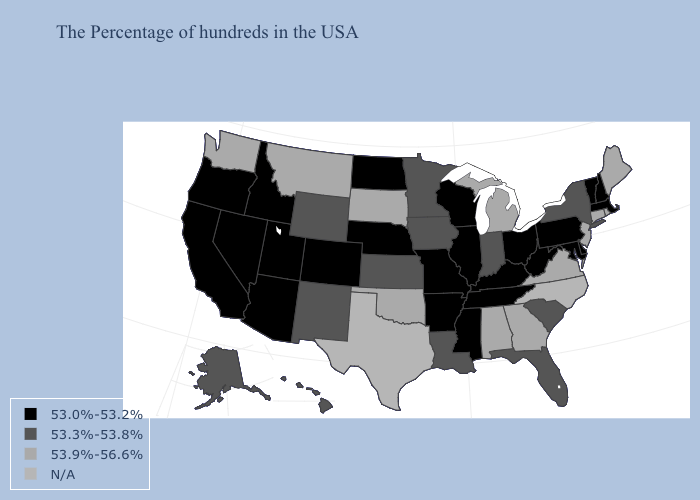Which states hav the highest value in the West?
Quick response, please. Montana, Washington. What is the value of Missouri?
Write a very short answer. 53.0%-53.2%. Name the states that have a value in the range 53.0%-53.2%?
Answer briefly. Massachusetts, New Hampshire, Vermont, Delaware, Maryland, Pennsylvania, West Virginia, Ohio, Kentucky, Tennessee, Wisconsin, Illinois, Mississippi, Missouri, Arkansas, Nebraska, North Dakota, Colorado, Utah, Arizona, Idaho, Nevada, California, Oregon. What is the lowest value in the USA?
Give a very brief answer. 53.0%-53.2%. What is the value of Louisiana?
Quick response, please. 53.3%-53.8%. What is the lowest value in the South?
Quick response, please. 53.0%-53.2%. How many symbols are there in the legend?
Concise answer only. 4. Which states have the lowest value in the Northeast?
Concise answer only. Massachusetts, New Hampshire, Vermont, Pennsylvania. Among the states that border Kentucky , which have the highest value?
Short answer required. Virginia. Which states hav the highest value in the Northeast?
Concise answer only. Maine, Rhode Island, Connecticut, New Jersey. Name the states that have a value in the range 53.9%-56.6%?
Quick response, please. Maine, Rhode Island, Connecticut, New Jersey, Virginia, Georgia, Michigan, Alabama, Oklahoma, South Dakota, Montana, Washington. Name the states that have a value in the range 53.3%-53.8%?
Write a very short answer. New York, South Carolina, Florida, Indiana, Louisiana, Minnesota, Iowa, Kansas, Wyoming, New Mexico, Alaska, Hawaii. Which states have the lowest value in the South?
Quick response, please. Delaware, Maryland, West Virginia, Kentucky, Tennessee, Mississippi, Arkansas. 